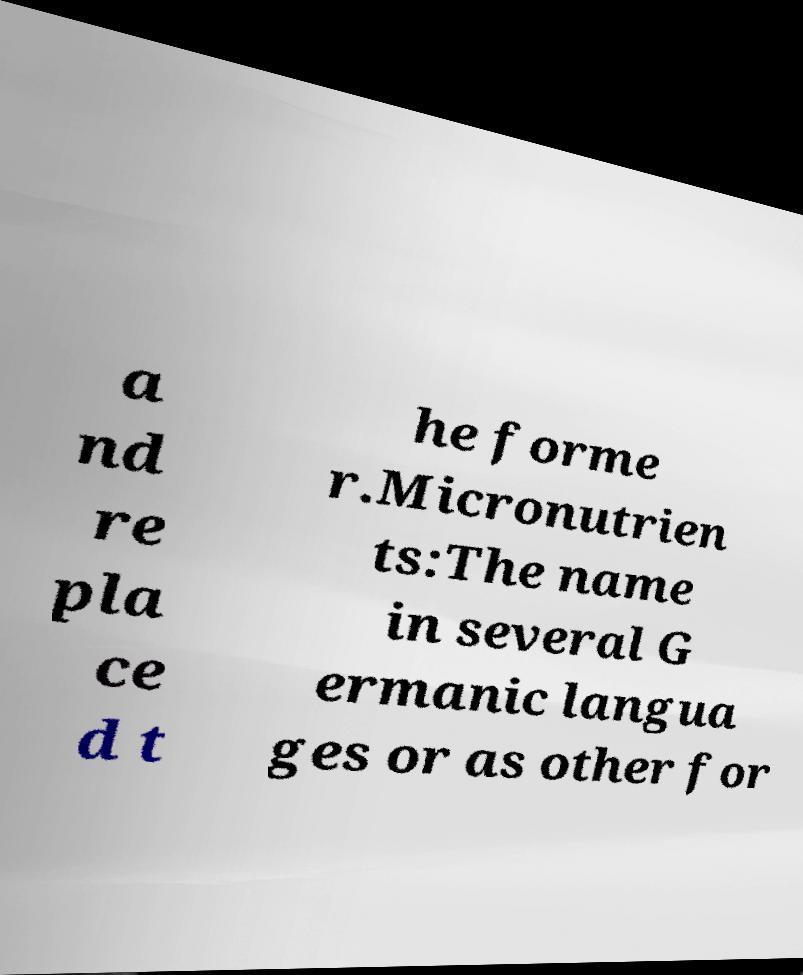For documentation purposes, I need the text within this image transcribed. Could you provide that? a nd re pla ce d t he forme r.Micronutrien ts:The name in several G ermanic langua ges or as other for 